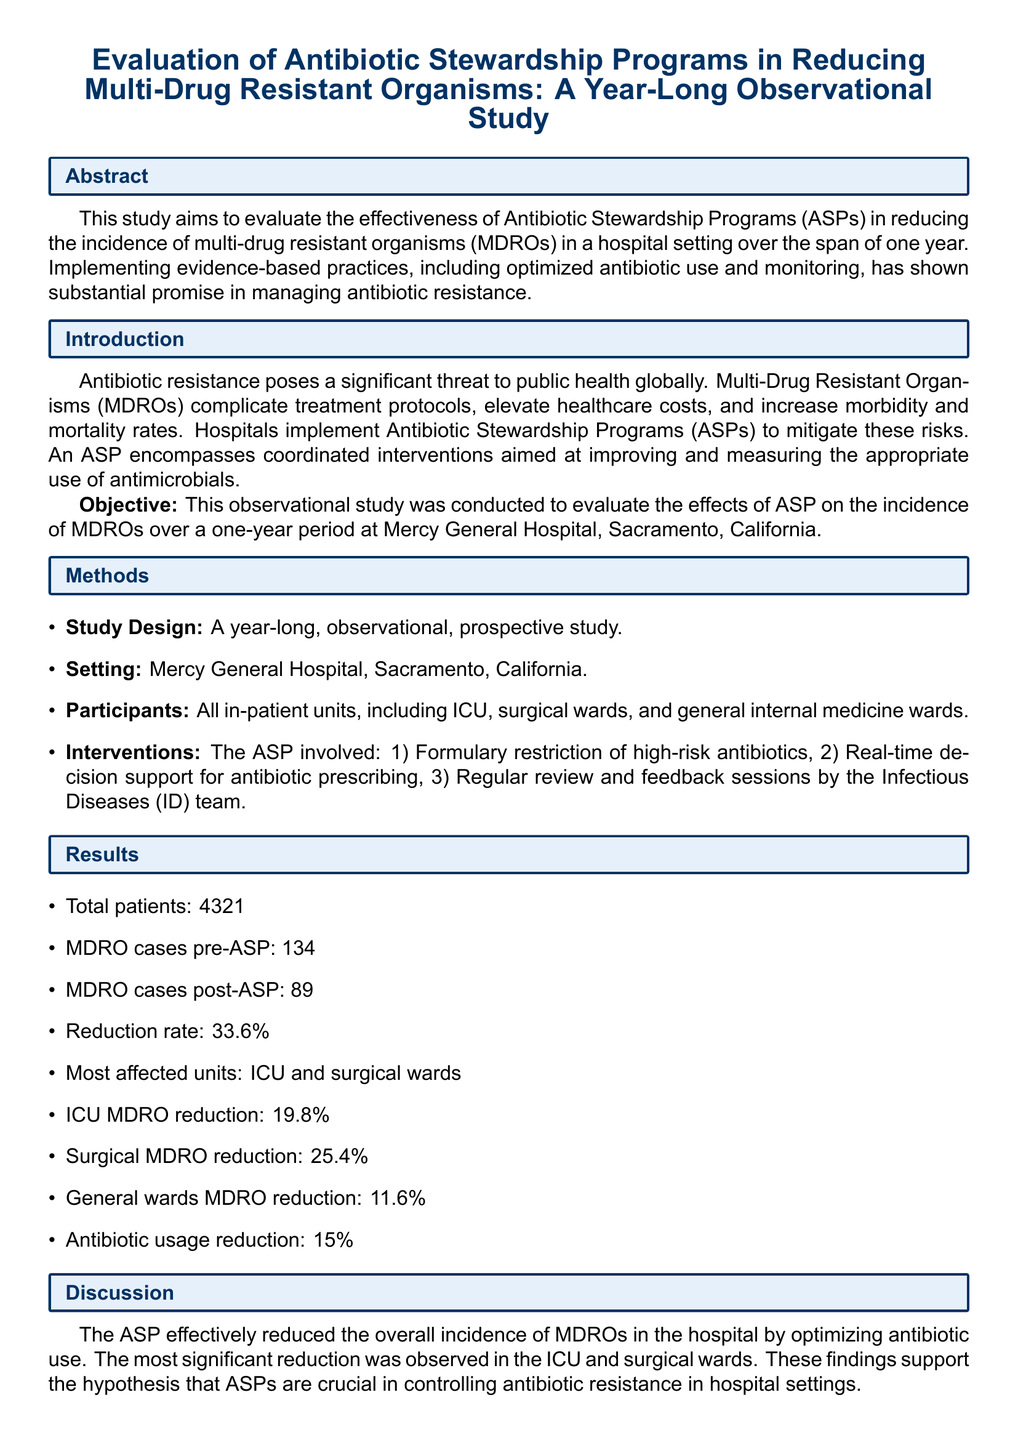What is the objective of the study? The objective of the study is to evaluate the effects of ASP on the incidence of MDROs over a one-year period at Mercy General Hospital, Sacramento, California.
Answer: evaluate the effects of ASP on the incidence of MDROs What was the reduction rate of MDRO cases post-ASP? The reduction rate is calculated by comparing the number of MDRO cases before and after the implementation of the ASP. The report states a reduction rate of 33.6%.
Answer: 33.6% How many total patients were included in the study? The total number of patients included in the study is explicitly stated in the results section. The document mentions a total of 4321 patients.
Answer: 4321 Which units showed the most significant reduction in MDRO cases? The document specifies that the ICU and surgical wards were the most affected units regarding the MDRO reduction after implementing the ASP.
Answer: ICU and surgical wards What was the antibiotic usage reduction percentage? The antibiotic usage reduction percentage can be found in the results section, indicating a reduction of 15%.
Answer: 15% What type of study design was conducted? The study design is clearly stated in the methods section, indicating it was a year-long, observational, prospective study.
Answer: observational, prospective study What are two strengths of the study mentioned in the discussion? The discussion identifies comprehensive data collection across multiple units and real-time implementation of ASP interventions as strengths of the study.
Answer: comprehensive data collection, real-time implementation What is one limitation of the study? The limitation of the study, as stated in the discussion, is that it is a single-center study, which implies a potential lack of generalizability.
Answer: single-center study 